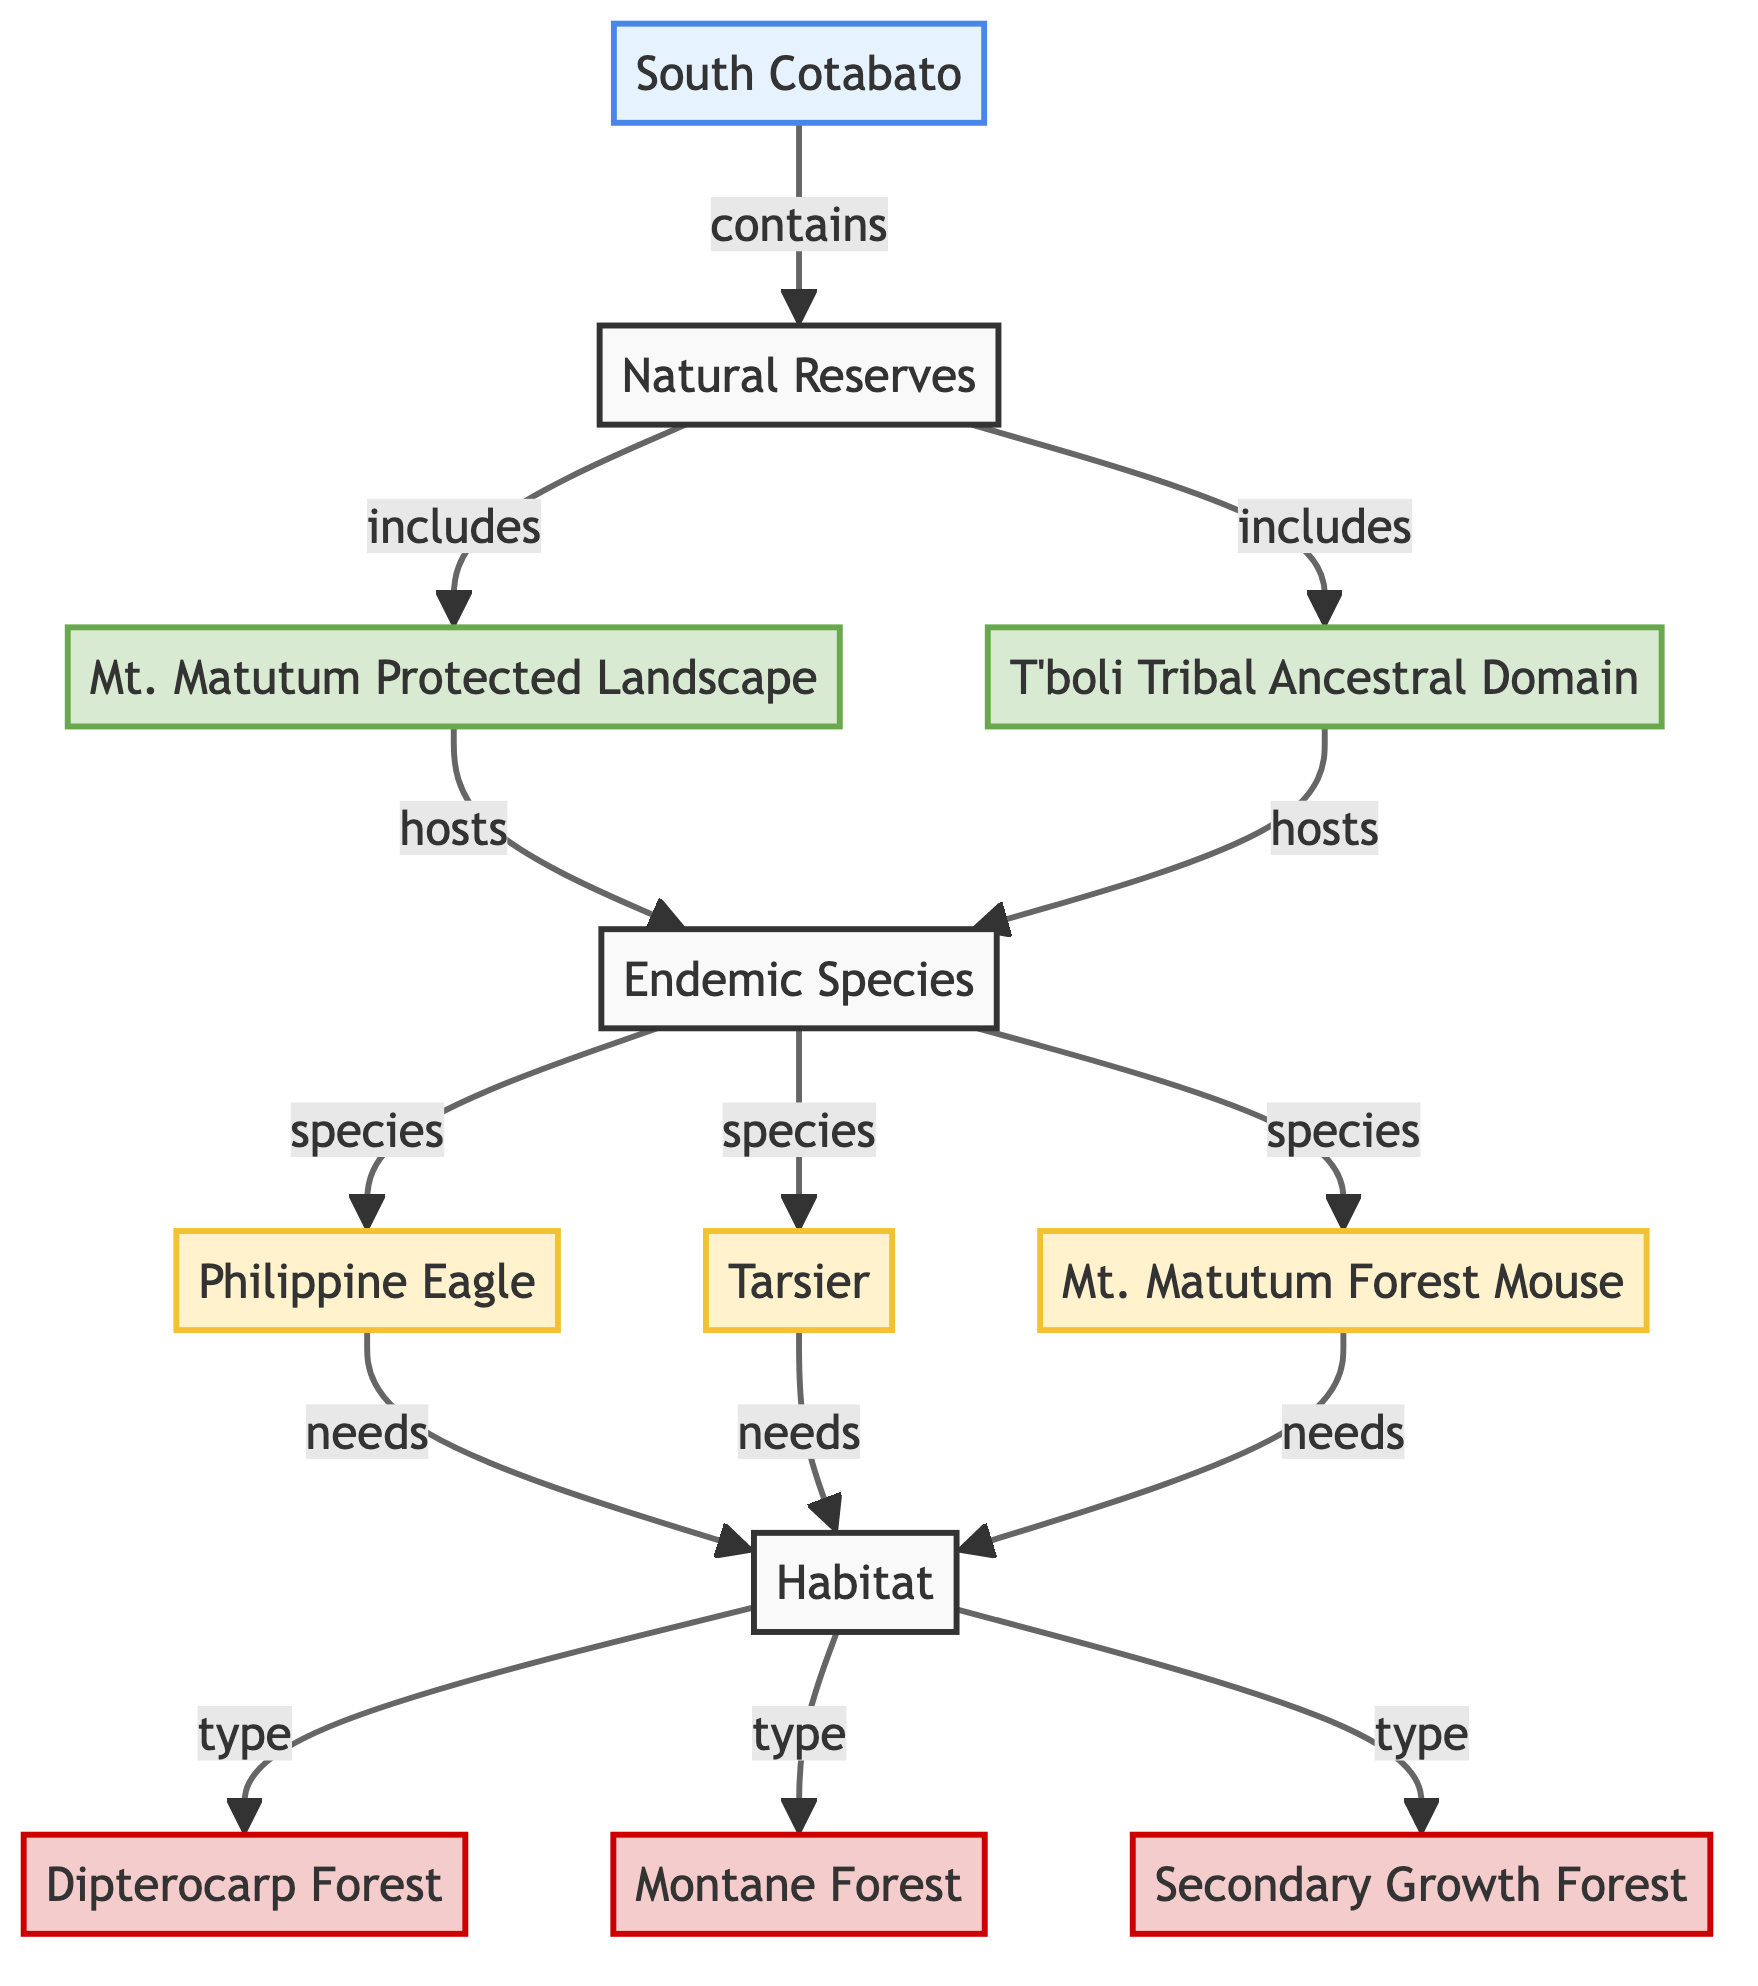What are the two natural reserves listed in the diagram? The diagram mentions two natural reserves - Mt. Matutum Protected Landscape and T'boli Tribal Ancestral Domain.
Answer: Mt. Matutum Protected Landscape, T'boli Tribal Ancestral Domain How many endemic species are shown in the diagram? The diagram lists three endemic species: Philippine Eagle, Tarsier, and Mt. Matutum Forest Mouse. Therefore, there are three species.
Answer: 3 Which habitat type is associated with all endemic species? Each endemic species is linked to the Habitat node, which contains Dipterocarp Forest, Montane Forest, and Secondary Growth Forest as the habitat types, indicating that they all share at least one common habitat type among these options.
Answer: Dipterocarp Forest, Montane Forest, Secondary Growth Forest What is the relationship between Mt. Matutum Protected Landscape and the Philippine Eagle? The diagram shows an arrow from the Mt. Matutum Protected Landscape to the Endemic Species, which includes the Philippine Eagle, indicating it hosts this species.
Answer: hosts Which species is specifically associated with the Mt. Matutum Protected Landscape? In the diagram, the Mt. Matutum Protected Landscape hosts the Endemic Species, including the Philippine Eagle, Tarsier, and Mt. Matutum Forest Mouse. Thus, all three species are associated but the question may refer to any one specific species linked to that reserve.
Answer: Philippine Eagle, Tarsier, Mt. Matutum Forest Mouse How many different habitat types are mentioned in the diagram? The diagram contains three distinct habitat types: Dipterocarp Forest, Montane Forest, and Secondary Growth Forest.
Answer: 3 